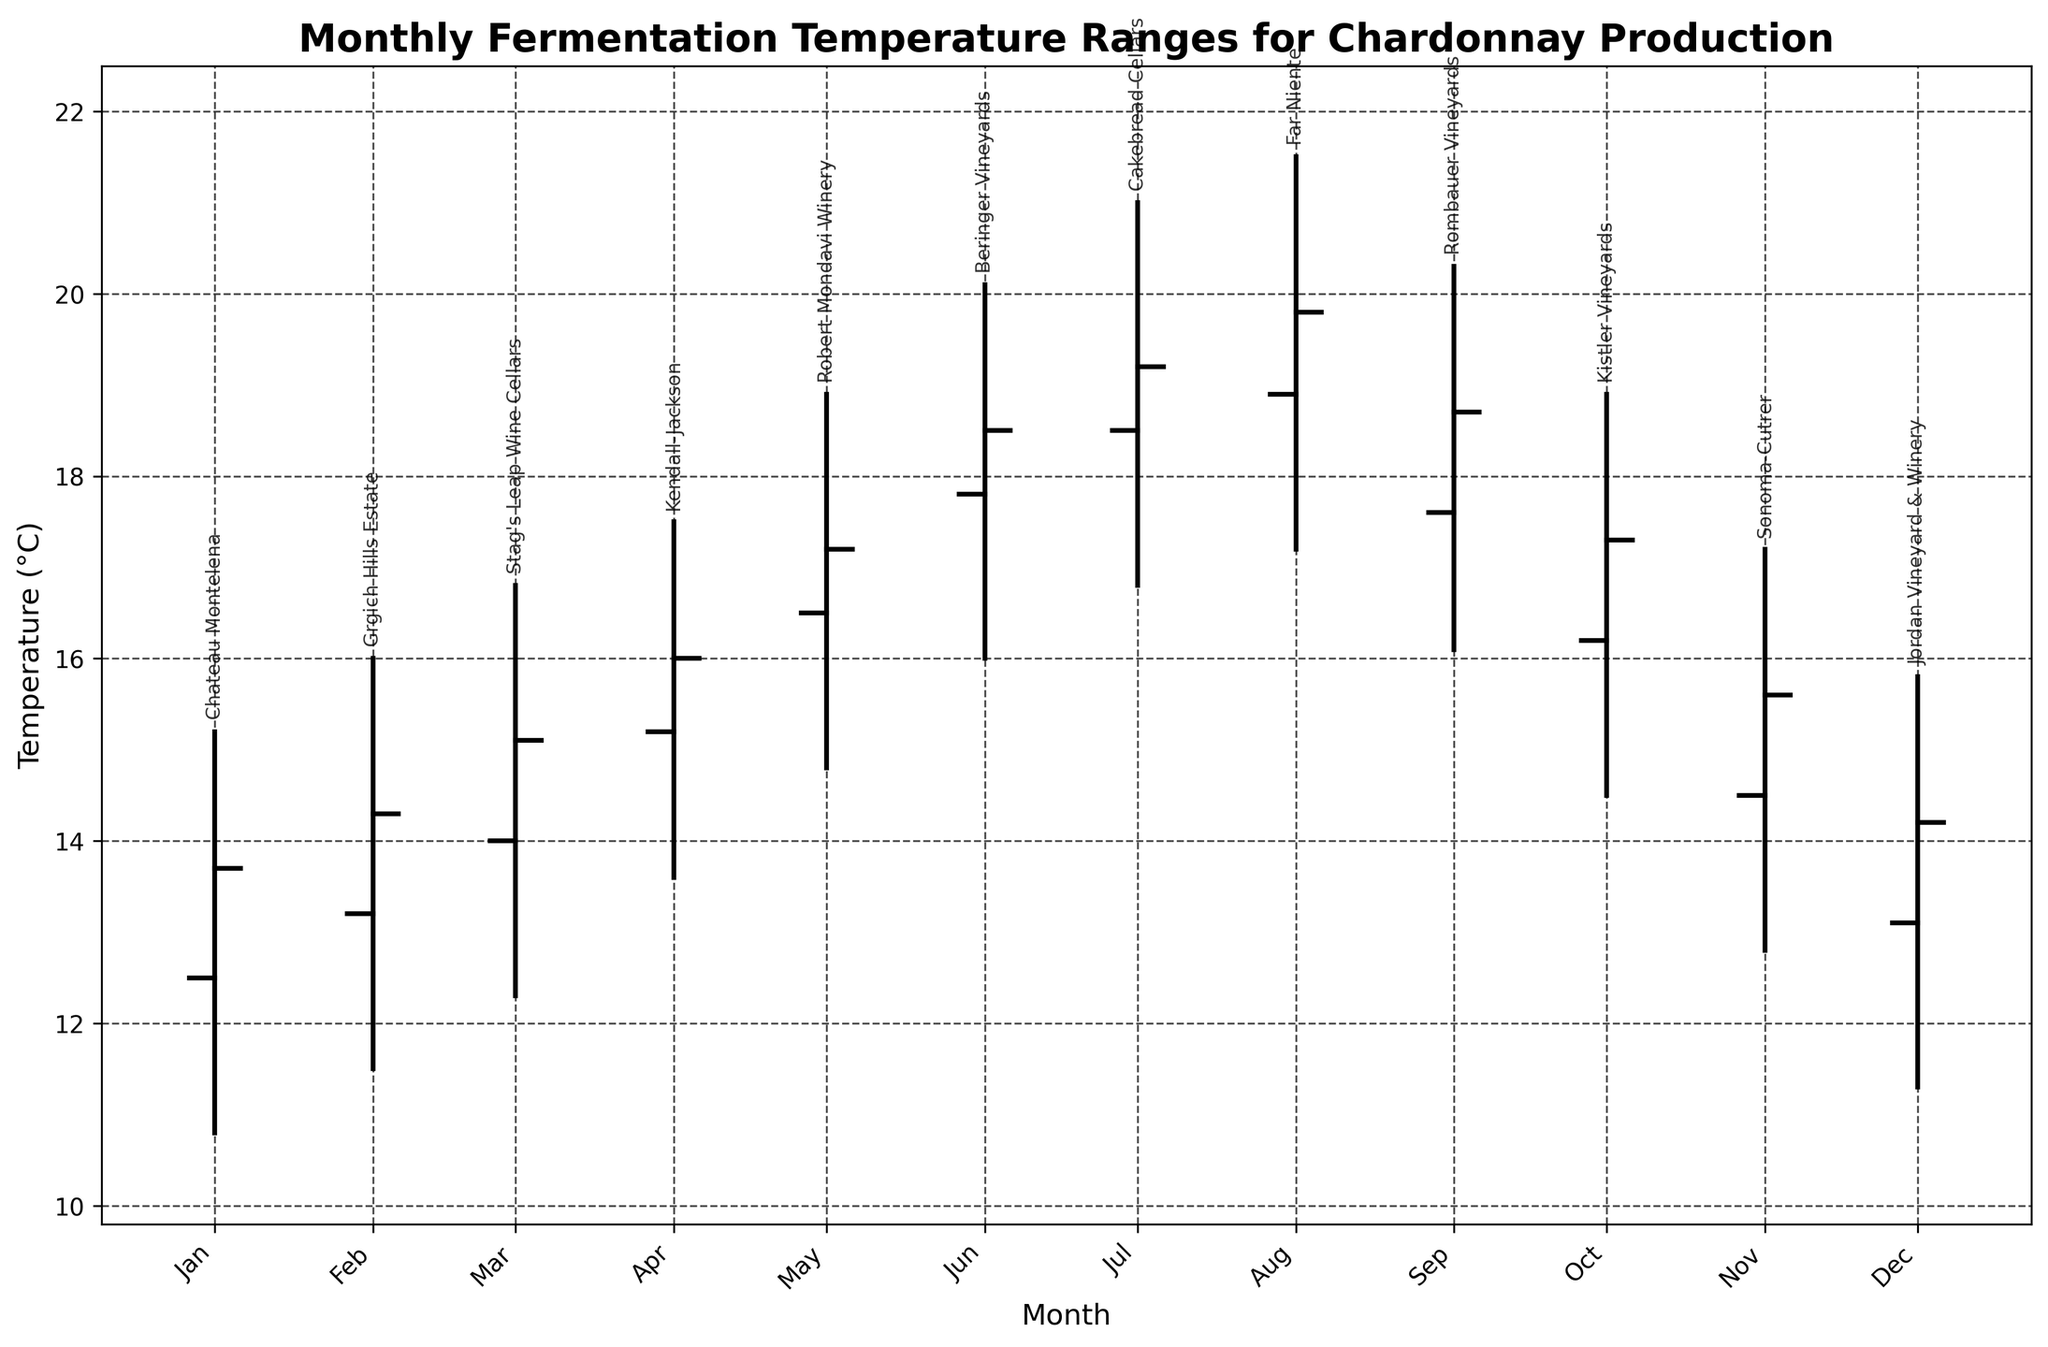What is the title of the figure? The title is usually located at the top of the figure. It is labeled prominently and describes what the chart is about.
Answer: Monthly Fermentation Temperature Ranges for Chardonnay Production What does the y-axis of the figure represent? The y-axis typically indicates the range of values being measured. In this figure, the y-axis labels help us understand what aspect of the data is being presented.
Answer: Temperature (°C) Which month has the highest fermentation temperature for any winery? To find this, look at the value of the highest point on the y-axis for each month. Identify which of these points is the highest overall. In this case, it occurs in August at Far Niente.
Answer: August What is the temperature range for July at Cakebread Cellars? To find this, look at the highest and lowest points of the vertical line for July at Cakebread Cellars and calculate the difference. The range is from 16.8°C to 21.0°C.
Answer: 4.2°C Which winery has the lowest closing temperature in December? The closing temperature is indicated by the horizontal line extending from the vertical line in December. The label next to it will identify the winery, which in this case is Jordan Vineyard & Winery with a close at 14.2°C.
Answer: Jordan Vineyard & Winery How much variation is there in fermentation temperatures for Beringer Vineyards in June? To assess the variation, look at the low and high points for June, subtract the low temperature from the high temperature: 20.1 - 16.0 = 4.1°C.
Answer: 4.1°C Which months show a temperature increase from the opening to the closing temperature? For each month, compare the opening and closing lines. If the closing line is higher than the opening line, then there's an increase.
Answer: All months show an increase What is the mean high temperature in April and May? Identify the high temperatures for April and May, which are 17.5°C and 18.9°C respectively. Then, calculate the mean: (17.5 + 18.9) / 2 = 18.2°C.
Answer: 18.2°C Which winery has the smallest range between low and high temperatures? Calculate the difference between the high and low temperatures for each winery and compare these differences to identify the smallest. In this data set, Sonoma-Cutrer in November has the narrowest range of 4.4°C.
Answer: Sonoma-Cutrer Considering all wineries, which month has the greatest temperature fluctuation? Temperature fluctuation is determined by the difference between the high and low temperatures for each month. Compare these differences across all months. The greatest fluctuation is in July at Cakebread Cellars (21.0°C - 16.8°C = 4.2°C).
Answer: July 